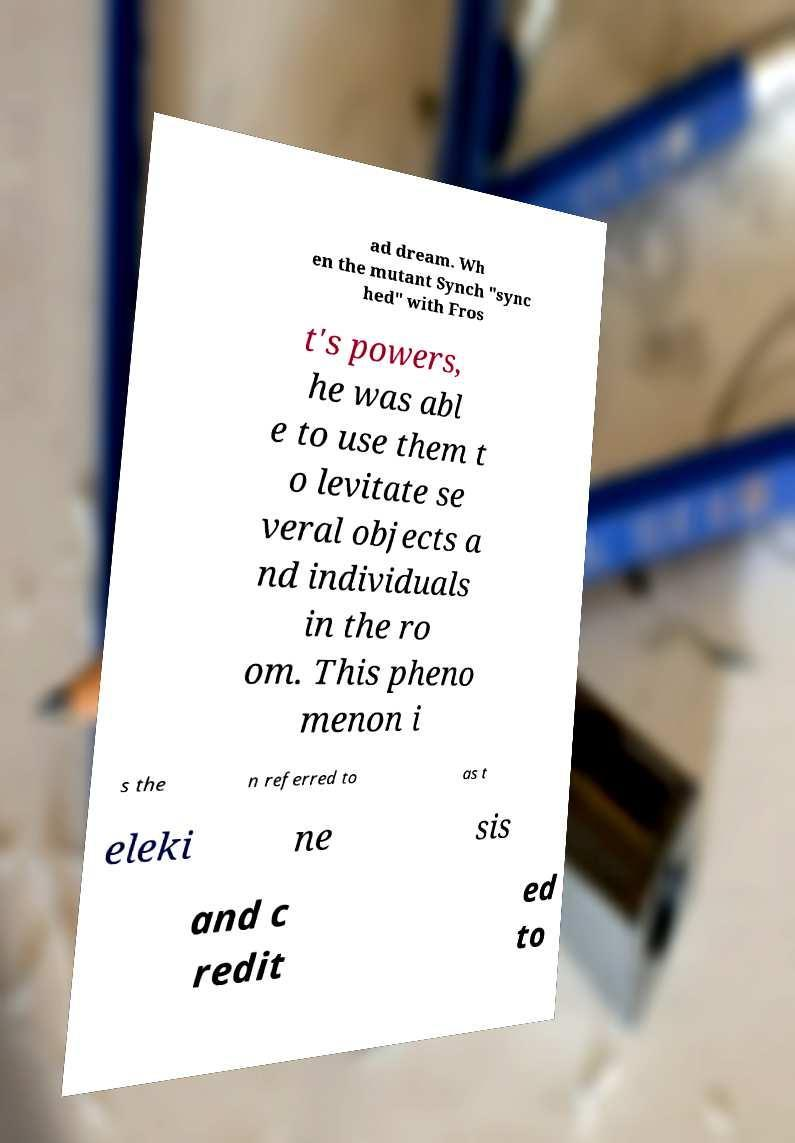Please read and relay the text visible in this image. What does it say? ad dream. Wh en the mutant Synch "sync hed" with Fros t's powers, he was abl e to use them t o levitate se veral objects a nd individuals in the ro om. This pheno menon i s the n referred to as t eleki ne sis and c redit ed to 